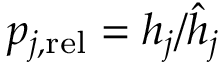Convert formula to latex. <formula><loc_0><loc_0><loc_500><loc_500>\begin{array} { r } { p _ { j , r e l } = h _ { j } / \hat { h } _ { j } } \end{array}</formula> 